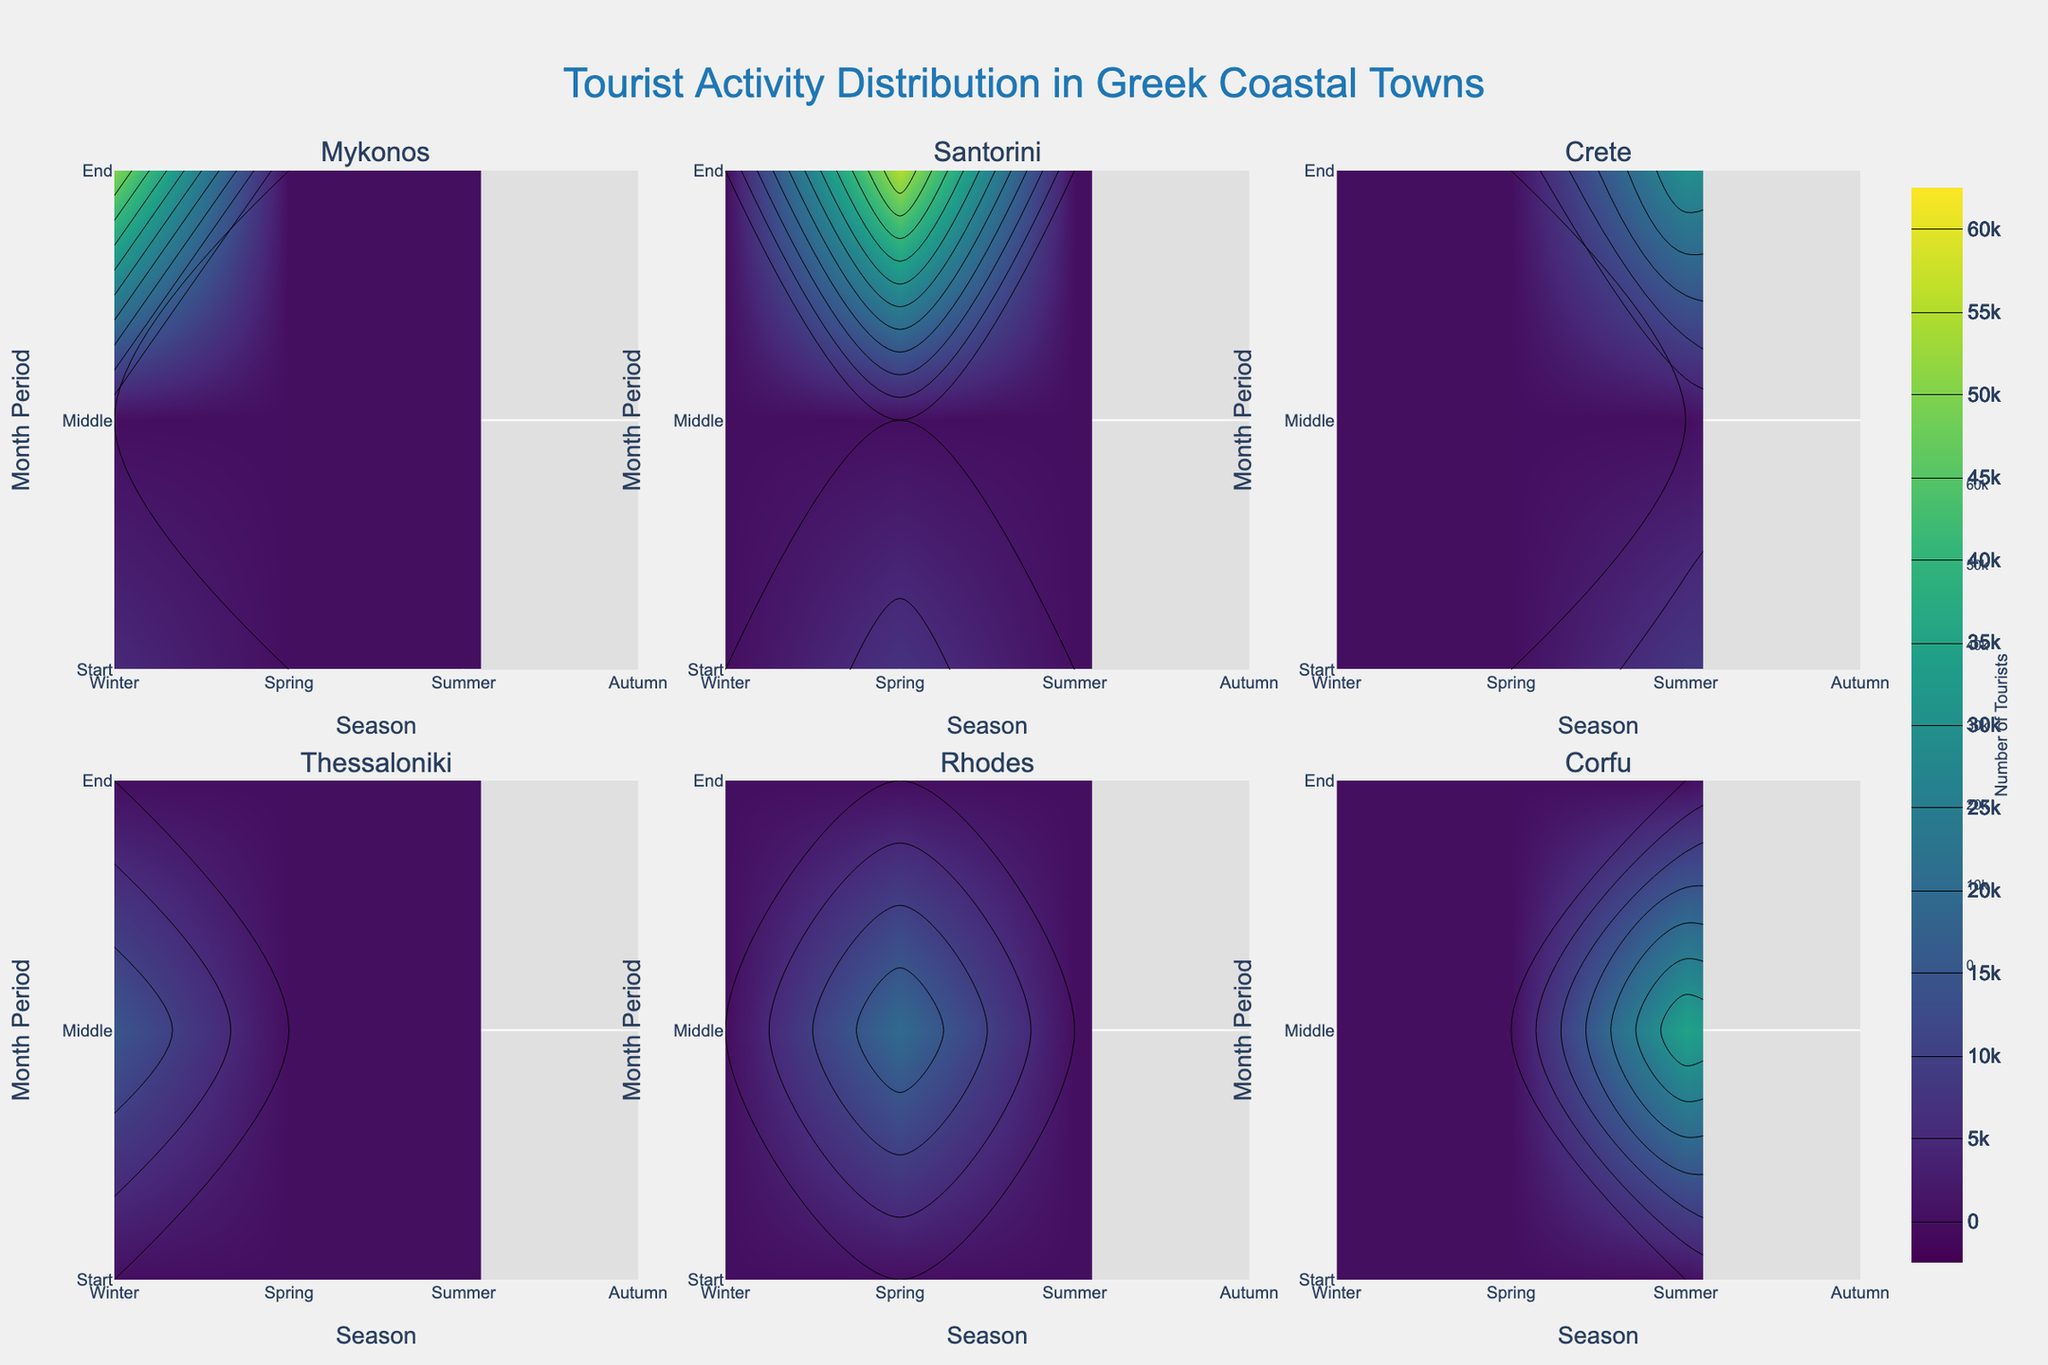How many tourists visit Mykonos in July? In the subplot for Mykonos, the contour plot will show that the number of tourists peaks during the summer months. Specifically, for July, the data corresponds to 50,000 tourists.
Answer: 50,000 Which coastal town has the highest tourist influx in August? By comparing the August data across all the subplots for the different coastal towns, the Santorini plot indicates that it has the highest tourist influx in August.
Answer: Santorini What trend do you observe in Thessaloniki regarding the number of tourists across the months? Examining the contour plot for Thessaloniki shows peaks during April and October, presumably correlated with Easter and the International Film Festival, indicating increased tourist influx during these months.
Answer: Peaks in April and October Which season attracts the most tourists to Greek coastal towns? Summarizing the data across all subplots, the tourist numbers are highest during the summer months (June, July, and August) in all coastal towns, indicating that summer is the most popular season.
Answer: Summer What is the tourist count difference between the peak and the trough in Rhodes? For Rhodes, the peak is in May during the Flower Festival (20,000 tourists), and the trough is in January (no significant event), resulting in 0 tourists. The difference is 20,000 - 0.
Answer: 20,000 Does Corfu see more tourists during Christmas or the Music Festival? In the subplot for Corfu, the contour plot shows more tourists in June for the Music Festival (35,000) compared to December for Christmas (7,000).
Answer: Music Festival Is there a correlation between festivals and tourist influx? Observing all subplots, it's evident that the number of tourists peaks significantly during local festivals for each town, indicating a strong positive correlation between festivals and tourist influx.
Answer: Yes Which month has the lowest tourist activity in Santorini? Analyzing the contours in the Santorini subplot over the months, January shows the lowest tourist activity with no specific events.
Answer: January 